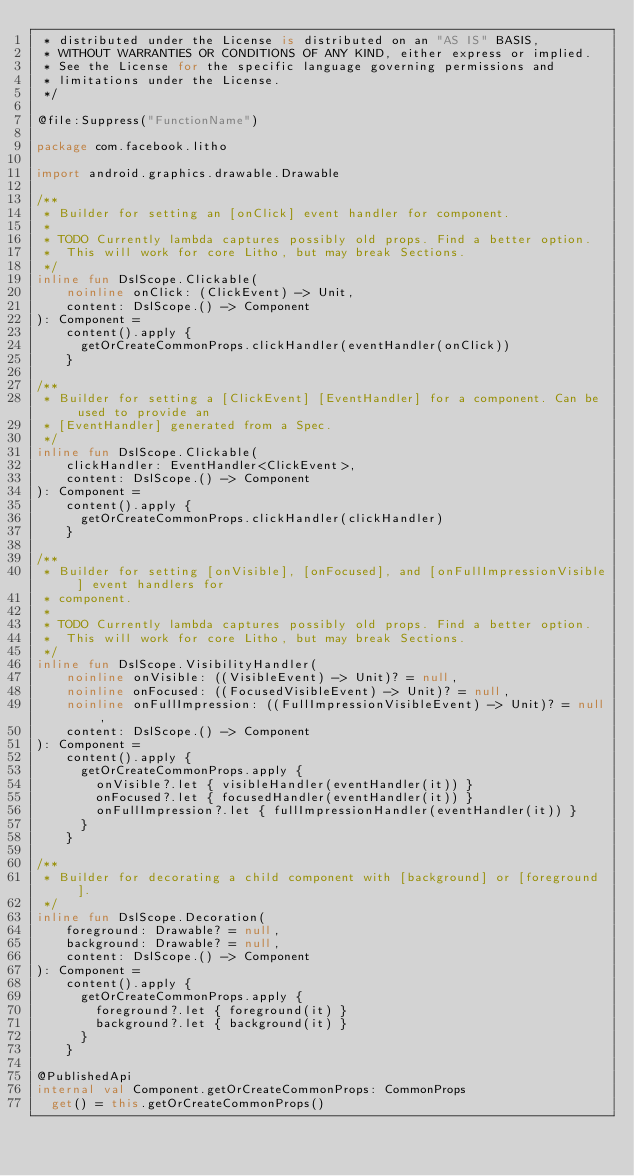Convert code to text. <code><loc_0><loc_0><loc_500><loc_500><_Kotlin_> * distributed under the License is distributed on an "AS IS" BASIS,
 * WITHOUT WARRANTIES OR CONDITIONS OF ANY KIND, either express or implied.
 * See the License for the specific language governing permissions and
 * limitations under the License.
 */

@file:Suppress("FunctionName")

package com.facebook.litho

import android.graphics.drawable.Drawable

/**
 * Builder for setting an [onClick] event handler for component.
 *
 * TODO Currently lambda captures possibly old props. Find a better option.
 *  This will work for core Litho, but may break Sections.
 */
inline fun DslScope.Clickable(
    noinline onClick: (ClickEvent) -> Unit,
    content: DslScope.() -> Component
): Component =
    content().apply {
      getOrCreateCommonProps.clickHandler(eventHandler(onClick))
    }

/**
 * Builder for setting a [ClickEvent] [EventHandler] for a component. Can be used to provide an
 * [EventHandler] generated from a Spec.
 */
inline fun DslScope.Clickable(
    clickHandler: EventHandler<ClickEvent>,
    content: DslScope.() -> Component
): Component =
    content().apply {
      getOrCreateCommonProps.clickHandler(clickHandler)
    }

/**
 * Builder for setting [onVisible], [onFocused], and [onFullImpressionVisible] event handlers for
 * component.
 *
 * TODO Currently lambda captures possibly old props. Find a better option.
 *  This will work for core Litho, but may break Sections.
 */
inline fun DslScope.VisibilityHandler(
    noinline onVisible: ((VisibleEvent) -> Unit)? = null,
    noinline onFocused: ((FocusedVisibleEvent) -> Unit)? = null,
    noinline onFullImpression: ((FullImpressionVisibleEvent) -> Unit)? = null,
    content: DslScope.() -> Component
): Component =
    content().apply {
      getOrCreateCommonProps.apply {
        onVisible?.let { visibleHandler(eventHandler(it)) }
        onFocused?.let { focusedHandler(eventHandler(it)) }
        onFullImpression?.let { fullImpressionHandler(eventHandler(it)) }
      }
    }

/**
 * Builder for decorating a child component with [background] or [foreground].
 */
inline fun DslScope.Decoration(
    foreground: Drawable? = null,
    background: Drawable? = null,
    content: DslScope.() -> Component
): Component =
    content().apply {
      getOrCreateCommonProps.apply {
        foreground?.let { foreground(it) }
        background?.let { background(it) }
      }
    }

@PublishedApi
internal val Component.getOrCreateCommonProps: CommonProps
  get() = this.getOrCreateCommonProps()
</code> 